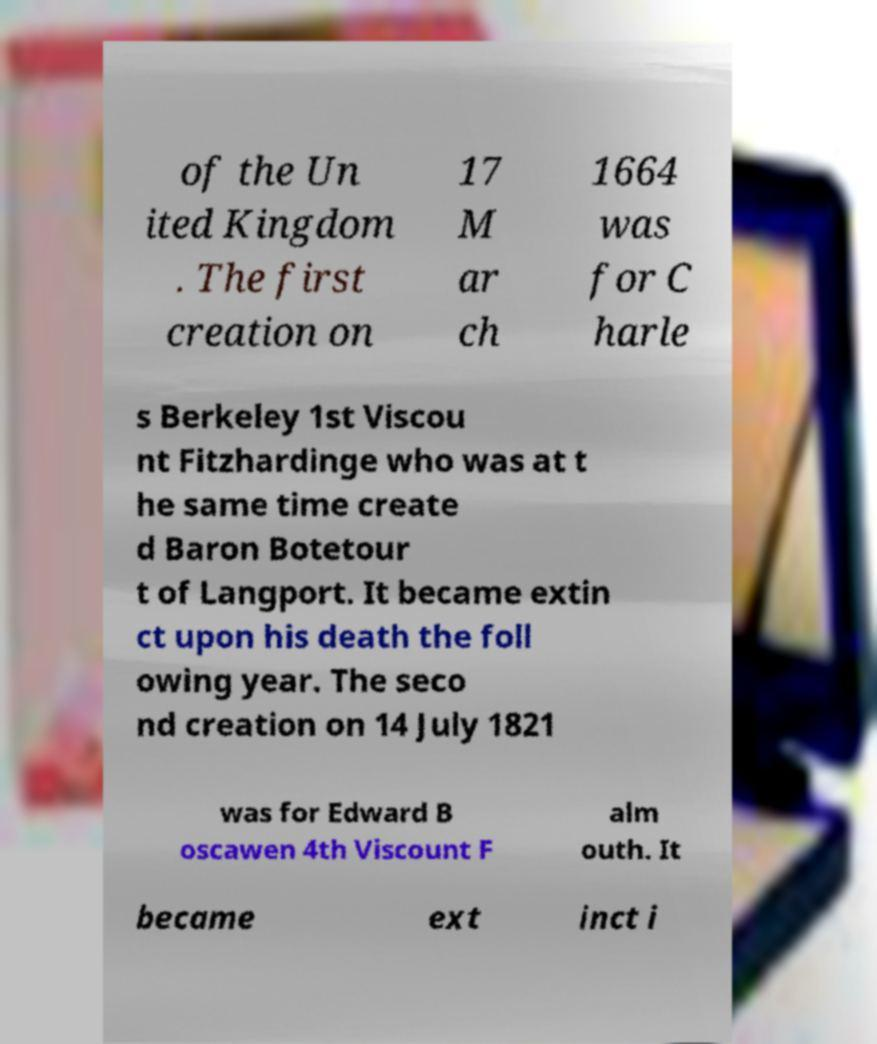What messages or text are displayed in this image? I need them in a readable, typed format. of the Un ited Kingdom . The first creation on 17 M ar ch 1664 was for C harle s Berkeley 1st Viscou nt Fitzhardinge who was at t he same time create d Baron Botetour t of Langport. It became extin ct upon his death the foll owing year. The seco nd creation on 14 July 1821 was for Edward B oscawen 4th Viscount F alm outh. It became ext inct i 